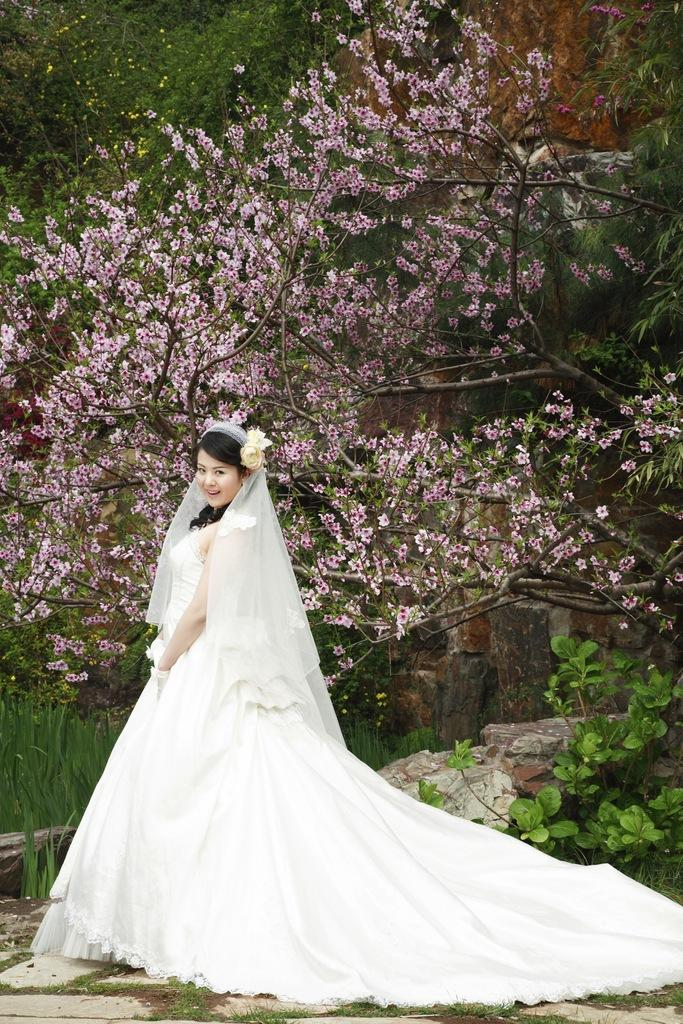Who or what is present in the image? There is a person in the image. What is the person doing or expressing? The person is smiling. What type of natural features can be seen in the image? There are rocks, plants, and trees in the image. What type of pollution can be seen in the image? There is no pollution visible in the image. What reason does the person have for smiling in the image? The provided facts do not give any information about the reason for the person's smile, so we cannot determine the reason from the image. 